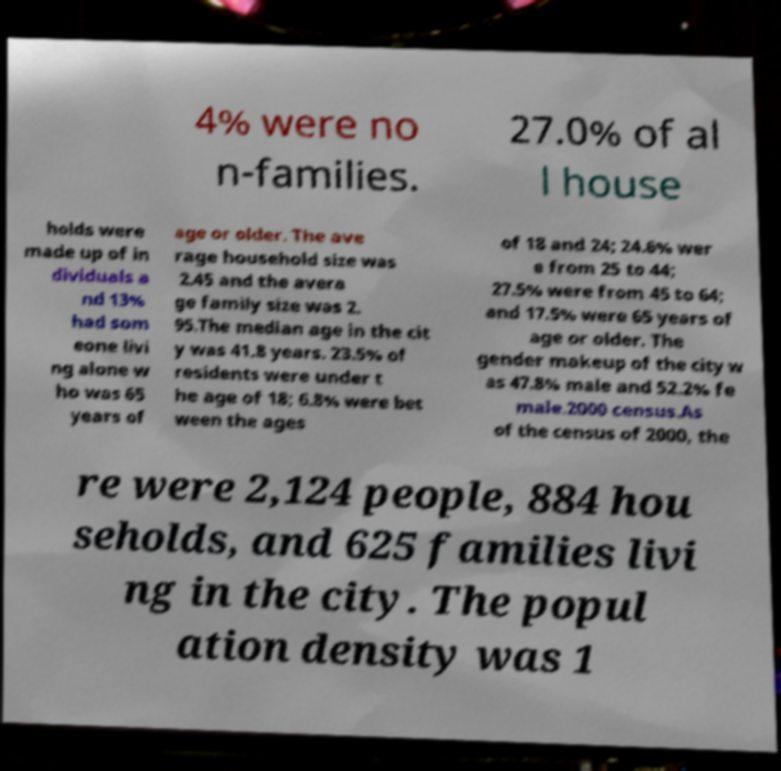Can you read and provide the text displayed in the image?This photo seems to have some interesting text. Can you extract and type it out for me? 4% were no n-families. 27.0% of al l house holds were made up of in dividuals a nd 13% had som eone livi ng alone w ho was 65 years of age or older. The ave rage household size was 2.45 and the avera ge family size was 2. 95.The median age in the cit y was 41.8 years. 23.5% of residents were under t he age of 18; 6.8% were bet ween the ages of 18 and 24; 24.6% wer e from 25 to 44; 27.5% were from 45 to 64; and 17.5% were 65 years of age or older. The gender makeup of the city w as 47.8% male and 52.2% fe male.2000 census.As of the census of 2000, the re were 2,124 people, 884 hou seholds, and 625 families livi ng in the city. The popul ation density was 1 